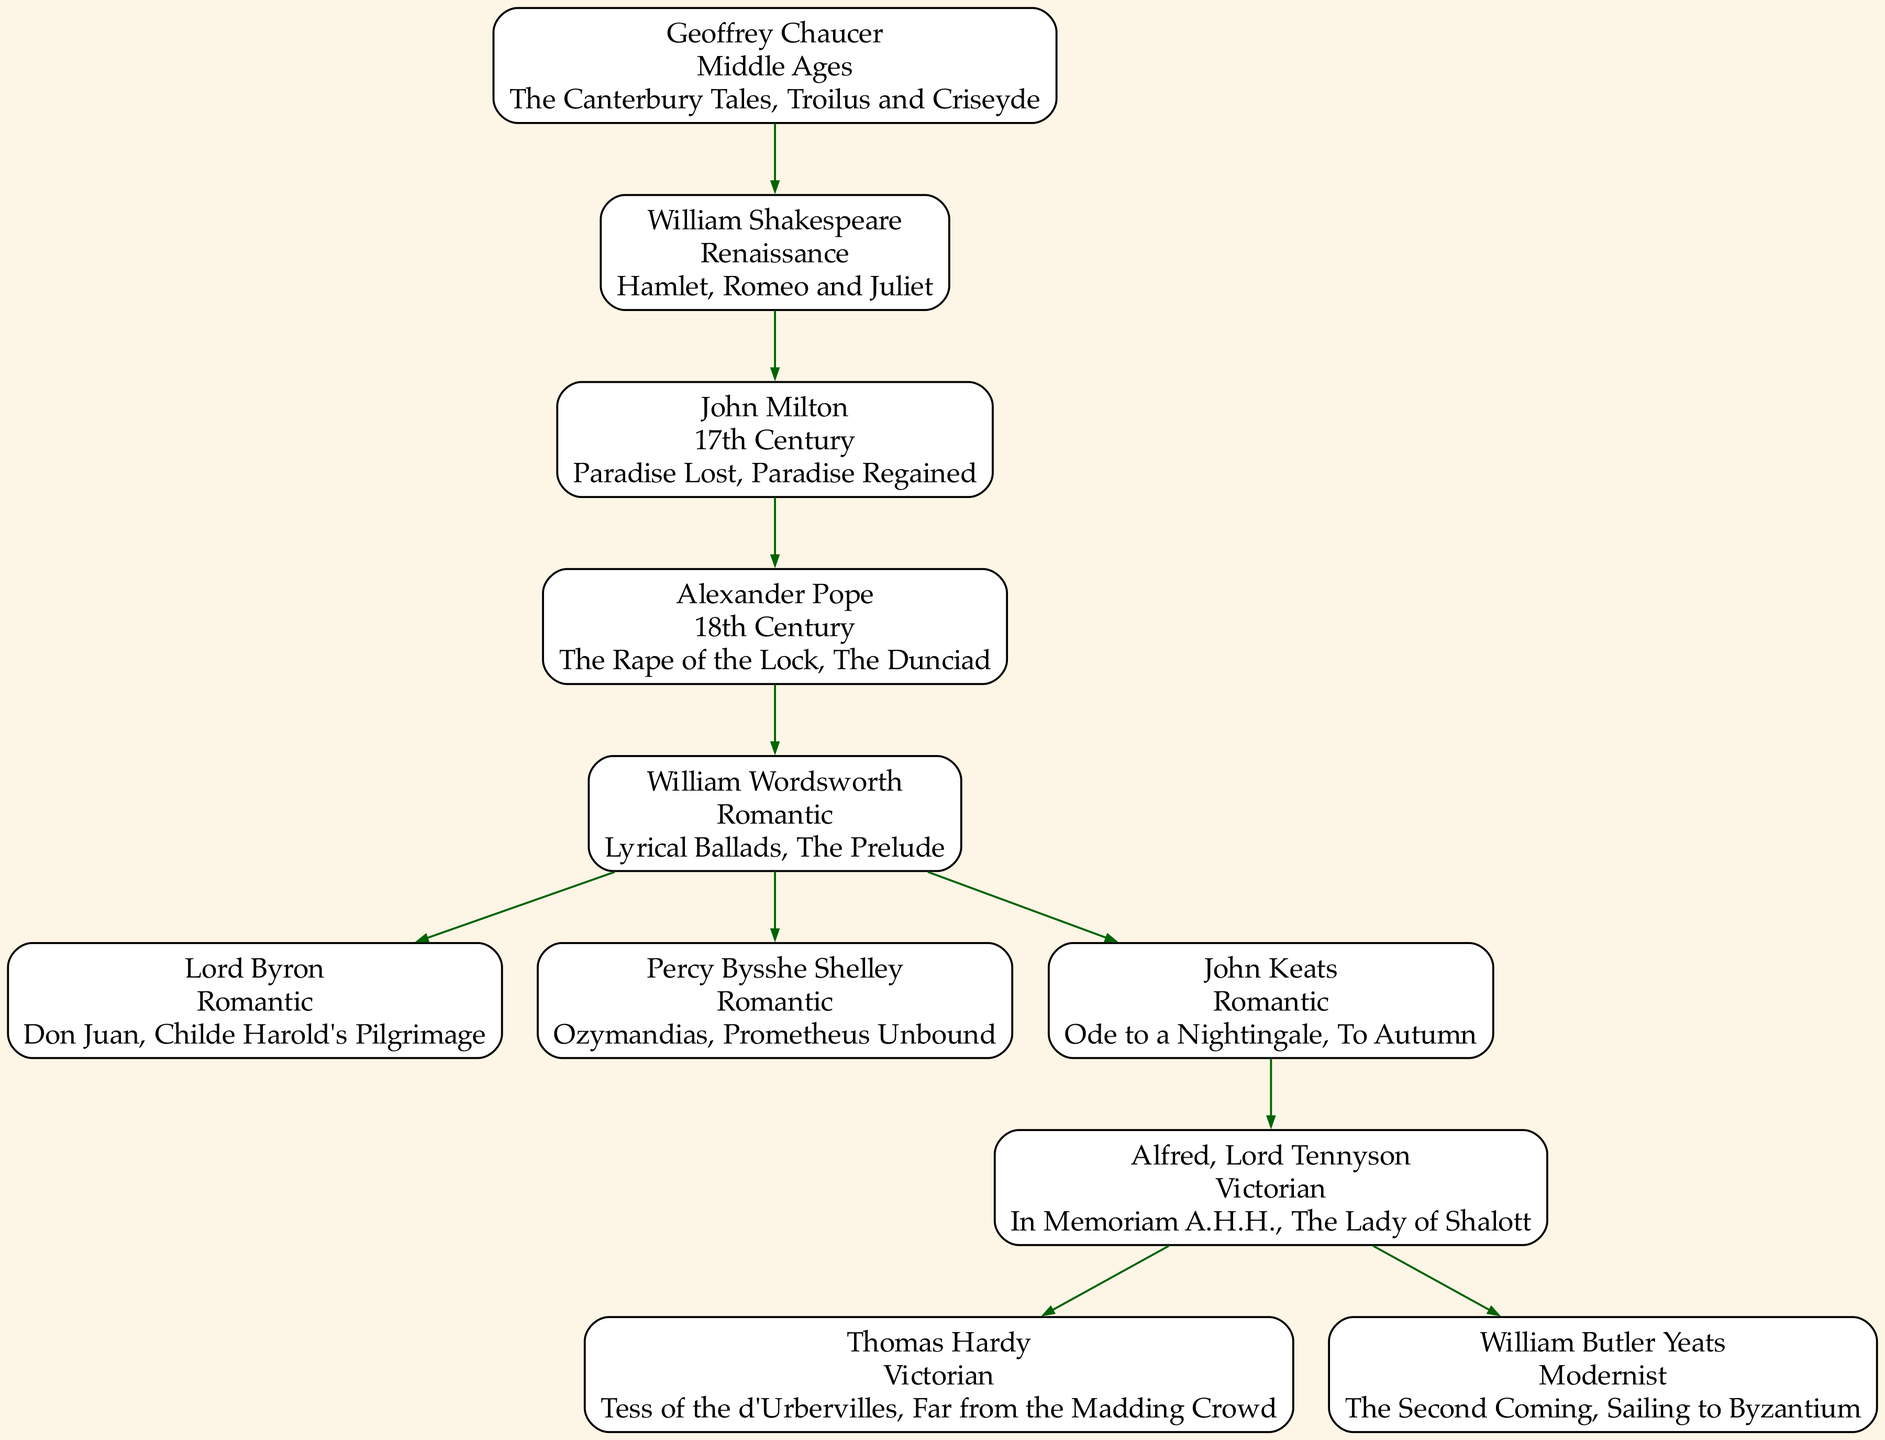What is the era of Geoffrey Chaucer? The diagram clearly states that Geoffrey Chaucer belongs to the Middle Ages era. This can be observed directly from the node representing Chaucer.
Answer: Middle Ages Which work is associated with William Shakespeare? The diagram shows that William Shakespeare has several works listed, one of which is 'Hamlet'. This information is found in his node.
Answer: Hamlet Who is the descendant of John Milton? According to the diagram, John Milton has a descendant named Alexander Pope. This relationship is indicated by the connection from Milton's node to Pope's node.
Answer: Alexander Pope How many major descendants does William Wordsworth have? In the diagram, William Wordsworth has three major descendants, each represented by a separate node branching out from his. The names are Lord Byron, Percy Bysshe Shelley, and John Keats.
Answer: 3 What is the relationship between Alfred, Lord Tennyson and William Butler Yeats? The diagram illustrates that Alfred, Lord Tennyson is a direct ancestor of William Butler Yeats, which is evidenced by the downward connection from Tennyson to Yeats within the family tree.
Answer: Ancestor Which author is known for the work 'Paradise Lost'? The diagram indicates that the work 'Paradise Lost' is closely associated with John Milton, as noted in his node within the family tree.
Answer: John Milton What is the hollowed number of total authors in the tree? A careful count of all unique author nodes in the diagram reveals that there are seven distinct authors represented. This includes Chaucer, Shakespeare, Milton, Pope, Wordsworth, Tennyson, and Yeats.
Answer: 7 Which literary era follows the Romantic period? In the family tree, it is evident that the Victorian era comes after the Romantic period. This is shown through the sequence of the authors depicted, specifically after John Keats transitioning to Tennyson.
Answer: Victorian What work did Percy Bysshe Shelley produce? The diagram states that 'Ozymandias' is one of the notable works by Percy Bysshe Shelley, clearly listed in his node.
Answer: Ozymandias 